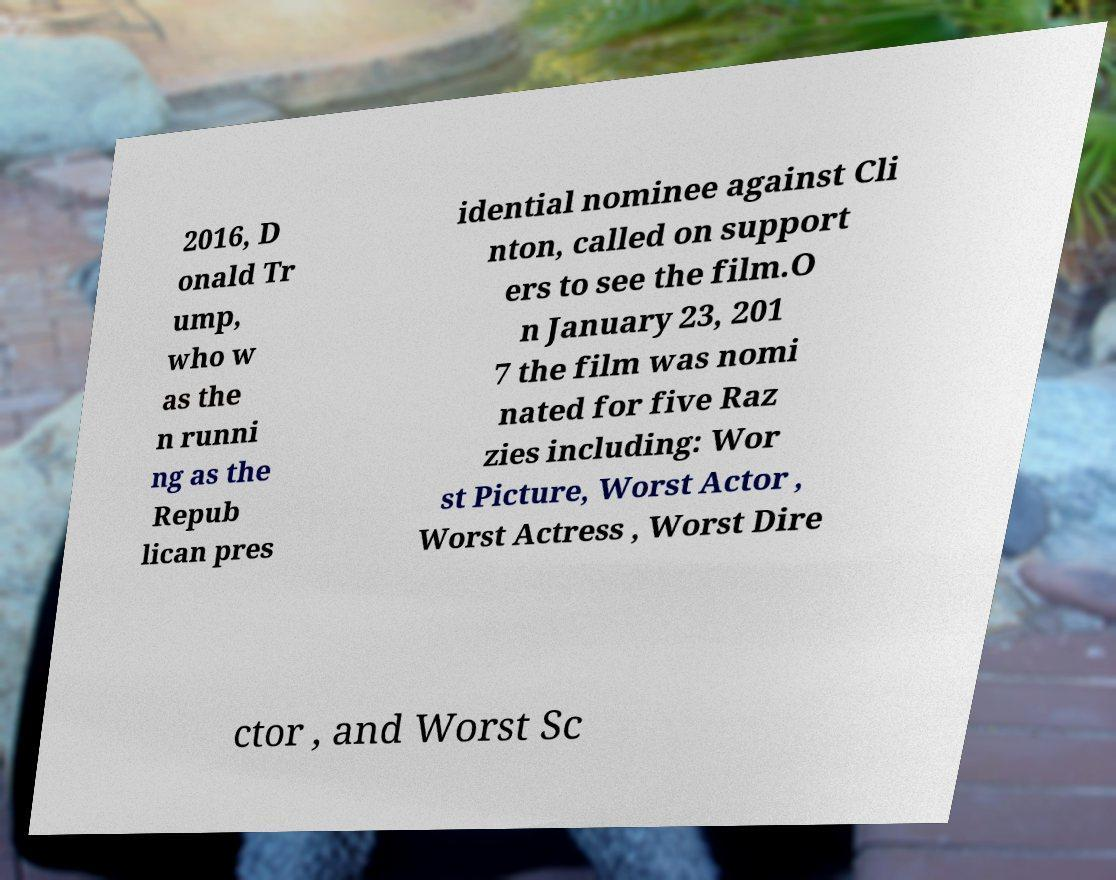Please read and relay the text visible in this image. What does it say? 2016, D onald Tr ump, who w as the n runni ng as the Repub lican pres idential nominee against Cli nton, called on support ers to see the film.O n January 23, 201 7 the film was nomi nated for five Raz zies including: Wor st Picture, Worst Actor , Worst Actress , Worst Dire ctor , and Worst Sc 